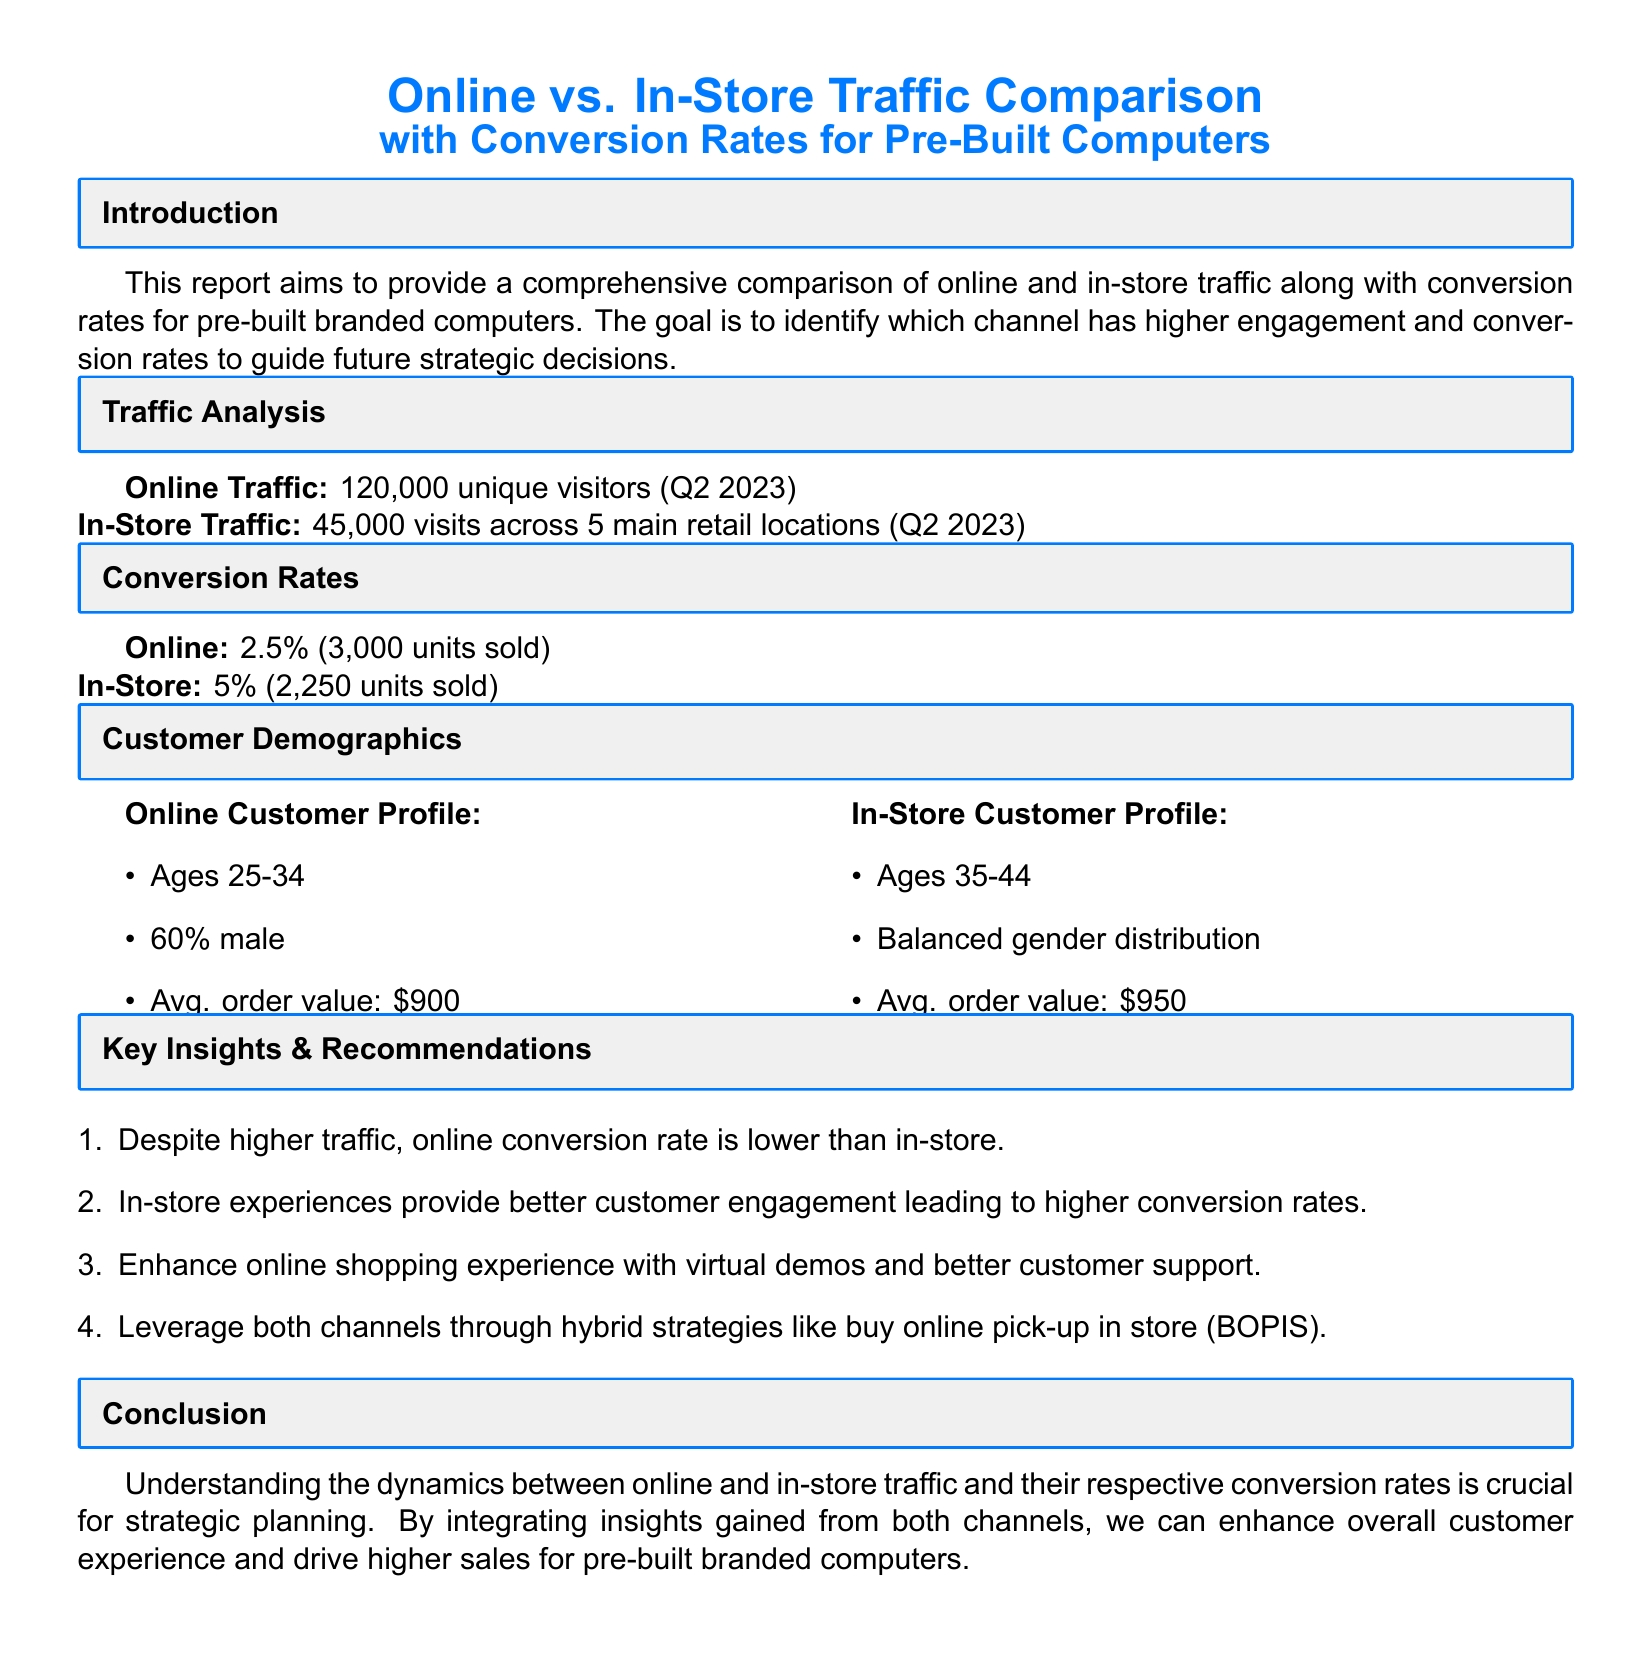What was the online traffic in Q2 2023? The document states that online traffic consisted of 120,000 unique visitors in Q2 2023.
Answer: 120,000 What was the in-store traffic across the retail locations? According to the report, the in-store traffic was 45,000 visits across 5 main retail locations in Q2 2023.
Answer: 45,000 What is the conversion rate for online sales? The report indicates that the conversion rate for online sales was 2.5%.
Answer: 2.5% How many units were sold online? The document mentions that 3,000 units were sold online.
Answer: 3,000 What age group constitutes the majority of online customers? The document states that the majority of online customers are ages 25-34.
Answer: Ages 25-34 Which customer profile has a higher average order value? The average order value for in-store customers is stated to be higher at $950 compared to online customers.
Answer: In-store customers What recommendation was made to enhance the online shopping experience? The report suggests enhancing the online shopping experience with virtual demos and better customer support.
Answer: Virtual demos Why are in-store experiences beneficial according to the report? The document suggests that in-store experiences provide better customer engagement which leads to higher conversion rates.
Answer: Better customer engagement What strategic recommendation involves both online and in-store channels? The document recommends leveraging both channels through hybrid strategies like buy online pick-up in store (BOPIS).
Answer: Buy online pick-up in store (BOPIS) 